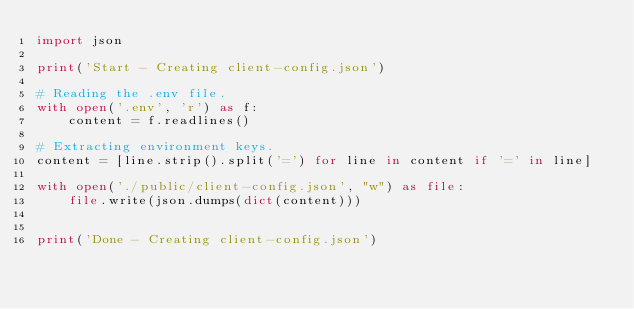Convert code to text. <code><loc_0><loc_0><loc_500><loc_500><_Python_>import json

print('Start - Creating client-config.json')

# Reading the .env file.
with open('.env', 'r') as f:
    content = f.readlines()

# Extracting environment keys.
content = [line.strip().split('=') for line in content if '=' in line]

with open('./public/client-config.json', "w") as file:
    file.write(json.dumps(dict(content)))


print('Done - Creating client-config.json')
</code> 